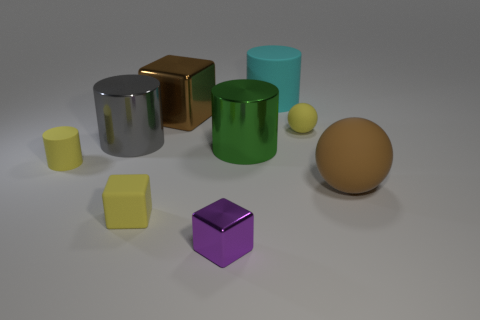Subtract 1 cylinders. How many cylinders are left? 3 Subtract all balls. How many objects are left? 7 Add 6 small yellow matte spheres. How many small yellow matte spheres exist? 7 Subtract 0 green spheres. How many objects are left? 9 Subtract all rubber cylinders. Subtract all small yellow rubber cylinders. How many objects are left? 6 Add 4 tiny matte things. How many tiny matte things are left? 7 